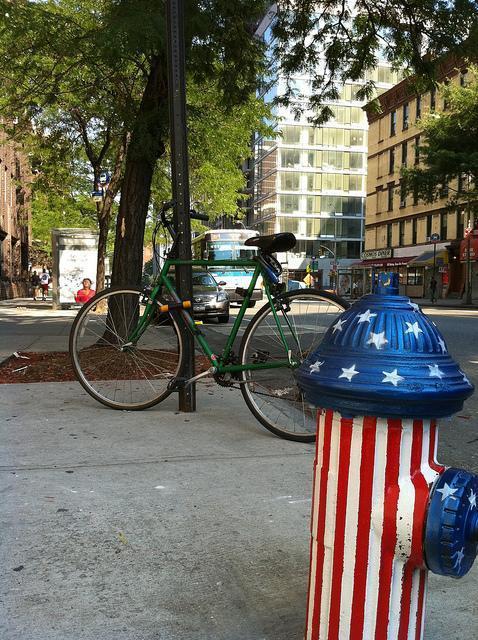Evaluate: Does the caption "The fire hydrant is far from the bus." match the image?
Answer yes or no. Yes. Does the description: "The bus is far away from the bicycle." accurately reflect the image?
Answer yes or no. Yes. Does the caption "The fire hydrant is in front of the bicycle." correctly depict the image?
Answer yes or no. Yes. 